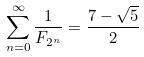<formula> <loc_0><loc_0><loc_500><loc_500>\sum _ { n = 0 } ^ { \infty } \frac { 1 } { F _ { 2 ^ { n } } } = \frac { 7 - \sqrt { 5 } } { 2 }</formula> 